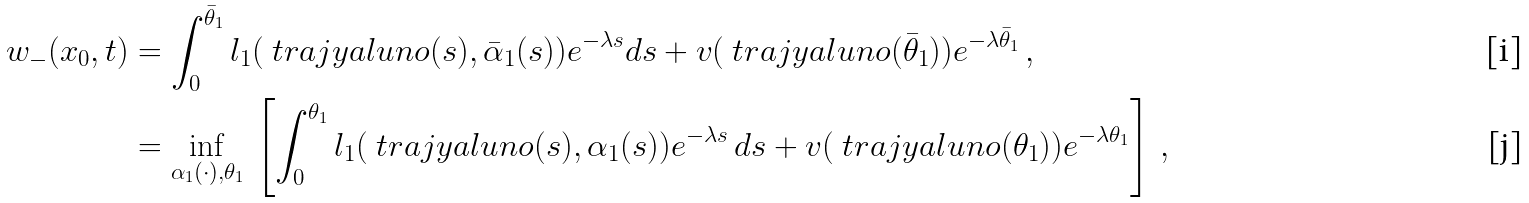<formula> <loc_0><loc_0><loc_500><loc_500>w _ { - } ( x _ { 0 } , t ) & = \int _ { 0 } ^ { \bar { \theta } _ { 1 } } l _ { 1 } ( \ t r a j y a l u n o ( s ) , \bar { \alpha } _ { 1 } ( s ) ) e ^ { - \lambda s } d s + v ( \ t r a j y a l u n o ( { \bar { \theta } } _ { 1 } ) ) e ^ { - \lambda { \bar { \theta } } _ { 1 } } \, , \\ & = \inf _ { \alpha _ { 1 } ( \cdot ) , \theta _ { 1 } } \, \left [ \int _ { 0 } ^ { \theta _ { 1 } } l _ { 1 } ( \ t r a j y a l u n o ( s ) , \alpha _ { 1 } ( s ) ) e ^ { - \lambda s } \, d s + v ( \ t r a j y a l u n o ( \theta _ { 1 } ) ) e ^ { - \lambda \theta _ { 1 } } \right ] \, ,</formula> 